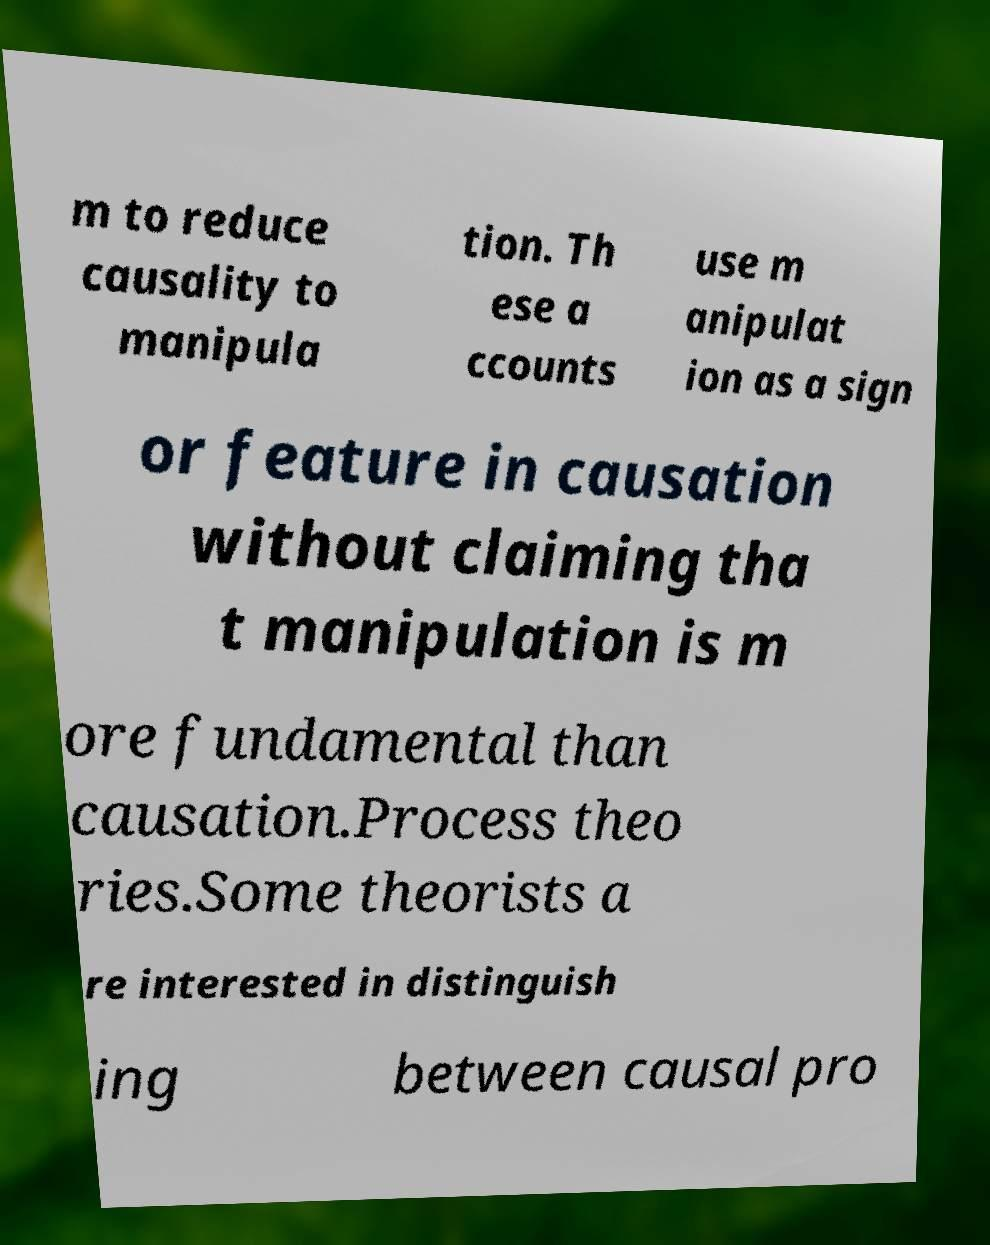Can you accurately transcribe the text from the provided image for me? m to reduce causality to manipula tion. Th ese a ccounts use m anipulat ion as a sign or feature in causation without claiming tha t manipulation is m ore fundamental than causation.Process theo ries.Some theorists a re interested in distinguish ing between causal pro 